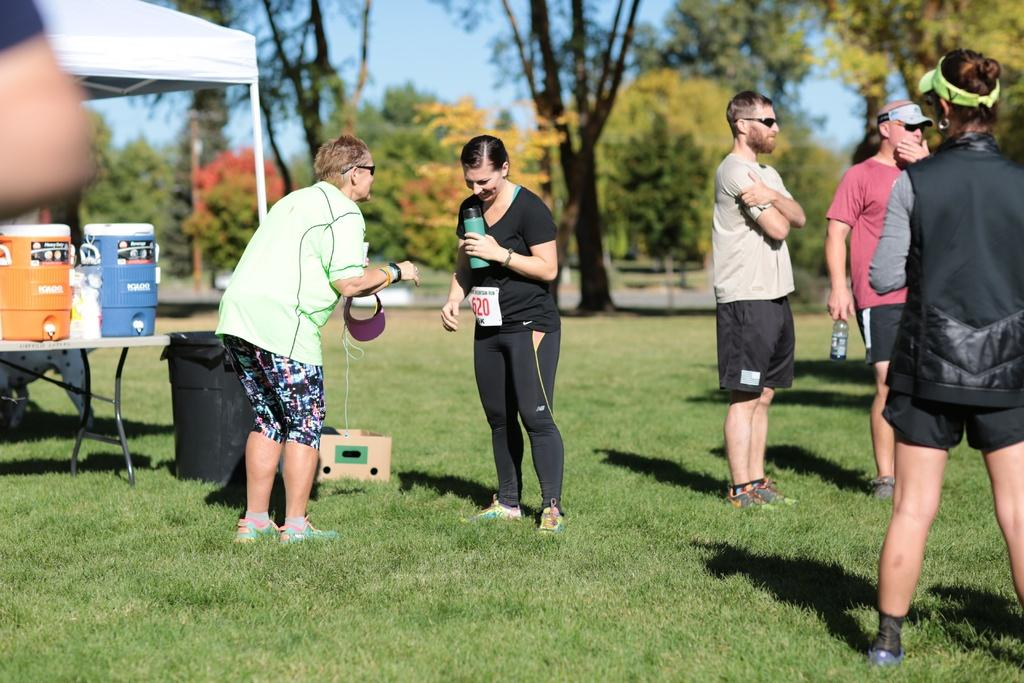How many people are in the image? There is a group of people in the image, but the exact number cannot be determined from the provided facts. What is the ground surface like where the people are standing? The people are standing on a grass ground. What structure is located beside the group of people? There is a tent beside the group of people. What type of vegetation can be seen in the image? There are trees visible in the image. Can you tell me how many requests the group of people made to the sidewalk in the image? There is no sidewalk present in the image, and therefore no requests can be made to it. 